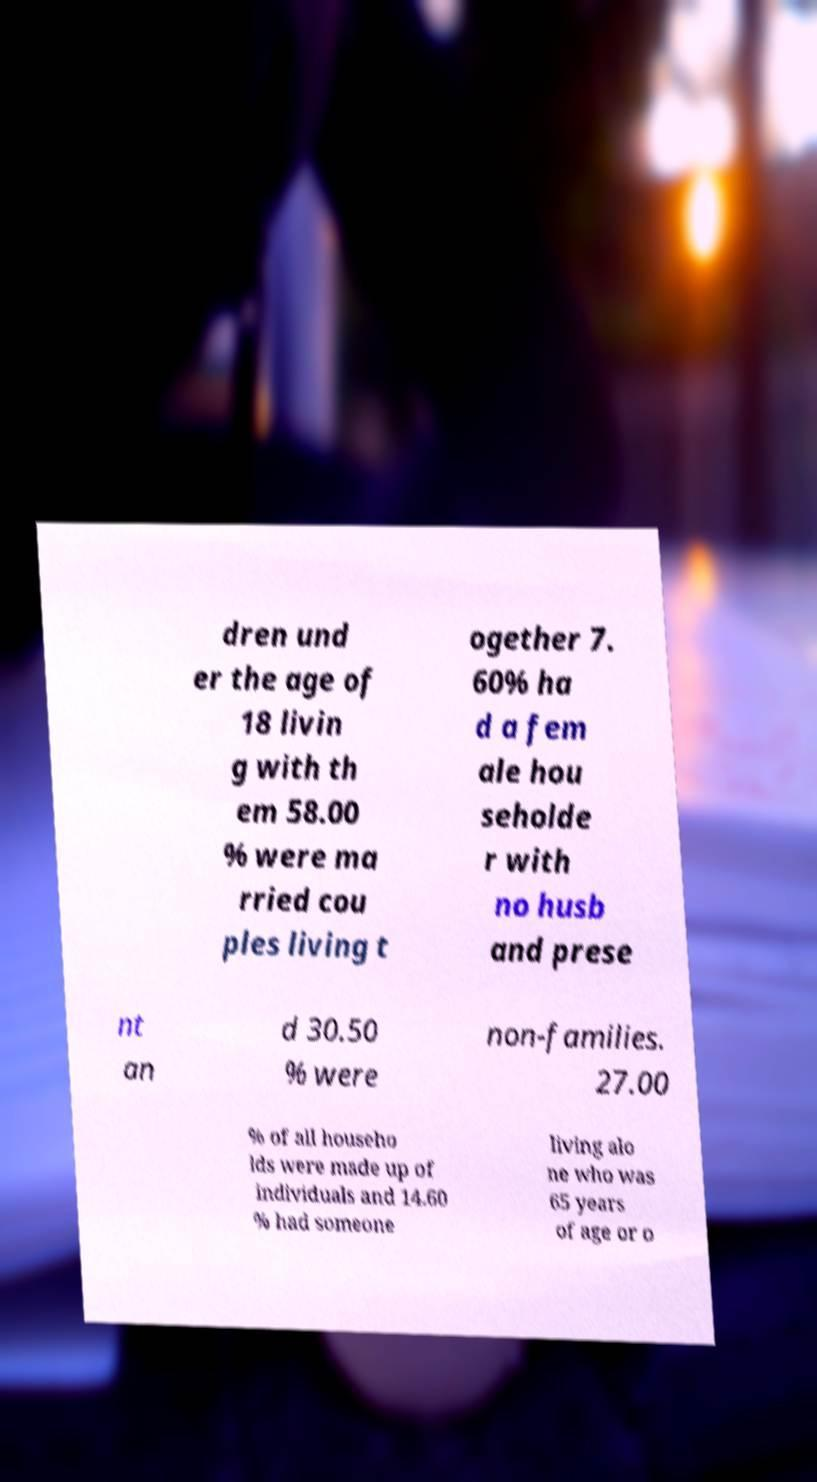Could you assist in decoding the text presented in this image and type it out clearly? dren und er the age of 18 livin g with th em 58.00 % were ma rried cou ples living t ogether 7. 60% ha d a fem ale hou seholde r with no husb and prese nt an d 30.50 % were non-families. 27.00 % of all househo lds were made up of individuals and 14.60 % had someone living alo ne who was 65 years of age or o 